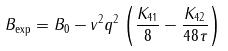<formula> <loc_0><loc_0><loc_500><loc_500>B _ { \text {exp} } = B _ { 0 } - v ^ { 2 } q ^ { 2 } \left ( \frac { K _ { 4 1 } } { 8 } - \frac { K _ { 4 2 } } { 4 8 \tau } \right )</formula> 